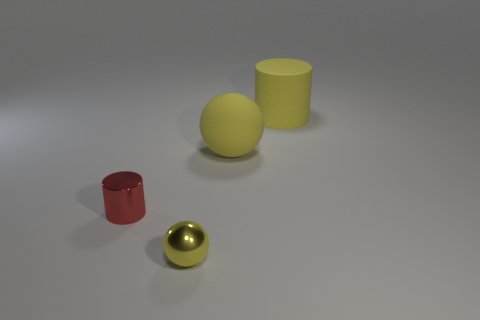The big yellow thing behind the big rubber object that is in front of the big cylinder is what shape?
Your answer should be compact. Cylinder. Are any red objects visible?
Make the answer very short. Yes. There is a ball that is to the right of the tiny thing right of the shiny cylinder; how many small red metallic cylinders are in front of it?
Make the answer very short. 1. Does the small red metallic object have the same shape as the large thing on the left side of the large yellow rubber cylinder?
Make the answer very short. No. Is the number of yellow metallic balls greater than the number of blue shiny balls?
Offer a terse response. Yes. Is there anything else that has the same size as the red metal cylinder?
Offer a very short reply. Yes. Does the object that is behind the yellow matte sphere have the same shape as the red thing?
Ensure brevity in your answer.  Yes. Are there more tiny metal balls that are behind the yellow metallic ball than red objects?
Give a very brief answer. No. There is a cylinder that is behind the tiny metal thing that is on the left side of the metal sphere; what color is it?
Provide a short and direct response. Yellow. How many yellow cylinders are there?
Keep it short and to the point. 1. 